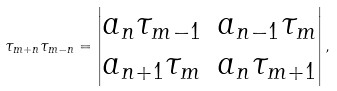<formula> <loc_0><loc_0><loc_500><loc_500>\tau _ { m + n } \tau _ { m - n } = \left | \begin{matrix} a _ { n } \tau _ { m - 1 } & a _ { n - 1 } \tau _ { m } \\ a _ { n + 1 } \tau _ { m } & a _ { n } \tau _ { m + 1 } \end{matrix} \right | ,</formula> 